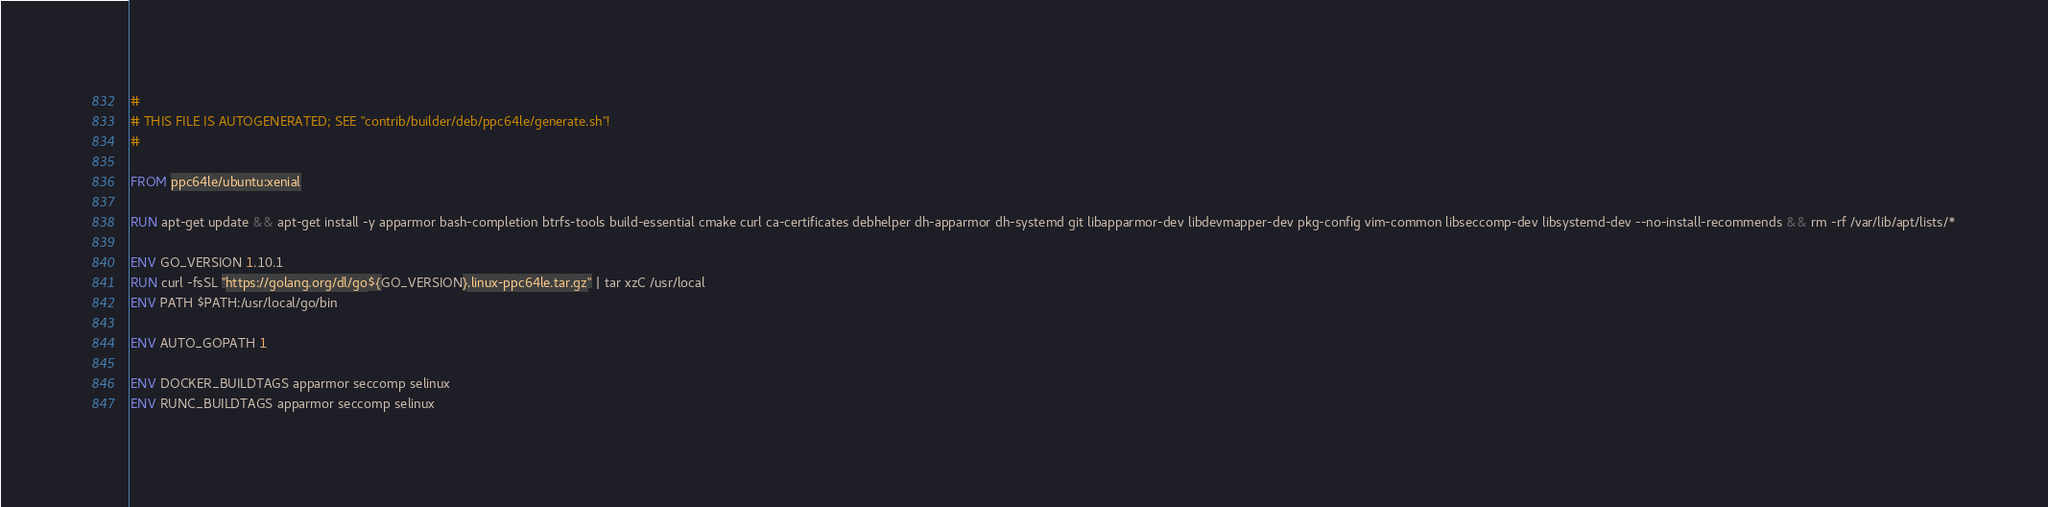<code> <loc_0><loc_0><loc_500><loc_500><_Dockerfile_>#
# THIS FILE IS AUTOGENERATED; SEE "contrib/builder/deb/ppc64le/generate.sh"!
#

FROM ppc64le/ubuntu:xenial

RUN apt-get update && apt-get install -y apparmor bash-completion btrfs-tools build-essential cmake curl ca-certificates debhelper dh-apparmor dh-systemd git libapparmor-dev libdevmapper-dev pkg-config vim-common libseccomp-dev libsystemd-dev --no-install-recommends && rm -rf /var/lib/apt/lists/*

ENV GO_VERSION 1.10.1
RUN curl -fsSL "https://golang.org/dl/go${GO_VERSION}.linux-ppc64le.tar.gz" | tar xzC /usr/local
ENV PATH $PATH:/usr/local/go/bin

ENV AUTO_GOPATH 1

ENV DOCKER_BUILDTAGS apparmor seccomp selinux
ENV RUNC_BUILDTAGS apparmor seccomp selinux
</code> 